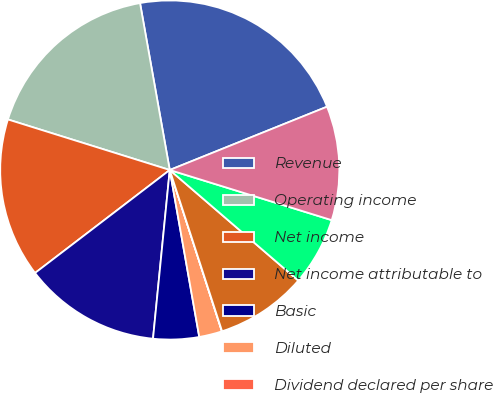Convert chart. <chart><loc_0><loc_0><loc_500><loc_500><pie_chart><fcel>Revenue<fcel>Operating income<fcel>Net income<fcel>Net income attributable to<fcel>Basic<fcel>Diluted<fcel>Dividend declared per share<fcel>High<fcel>Low<fcel>Close<nl><fcel>21.72%<fcel>17.38%<fcel>15.21%<fcel>13.04%<fcel>4.36%<fcel>2.19%<fcel>0.02%<fcel>8.7%<fcel>6.53%<fcel>10.87%<nl></chart> 